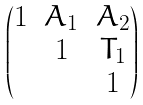Convert formula to latex. <formula><loc_0><loc_0><loc_500><loc_500>\begin{pmatrix} 1 & A _ { 1 } & A _ { 2 } \\ & 1 & T _ { 1 } \\ & & 1 \end{pmatrix}</formula> 